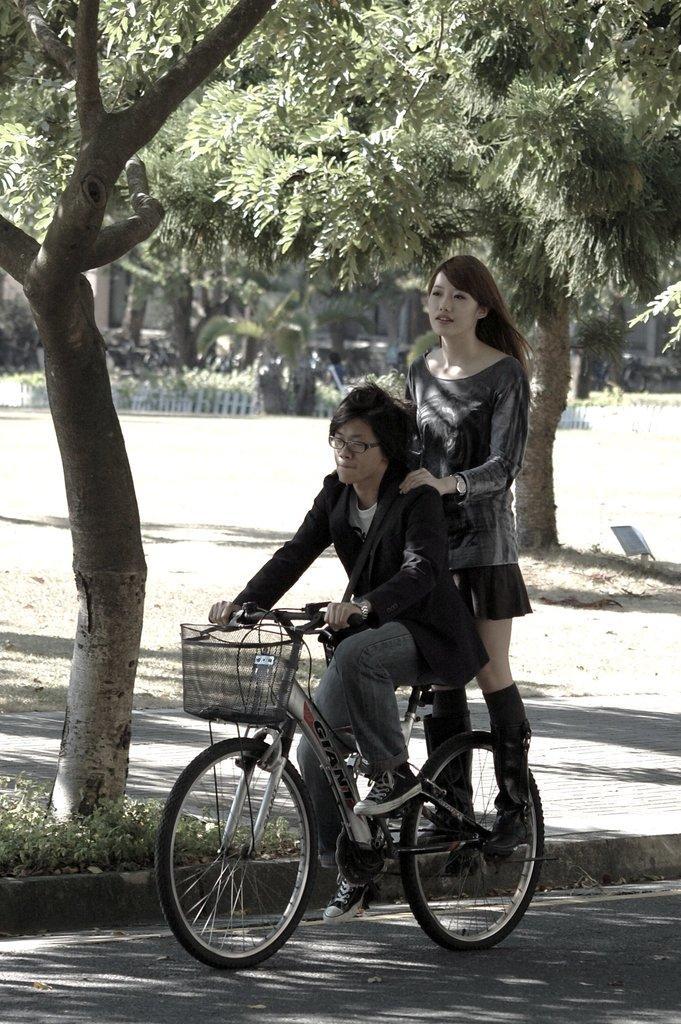How would you summarize this image in a sentence or two? There are two persons in this image. A man riding a bicycle and woman standing on it and at the background there are trees and a garden. 